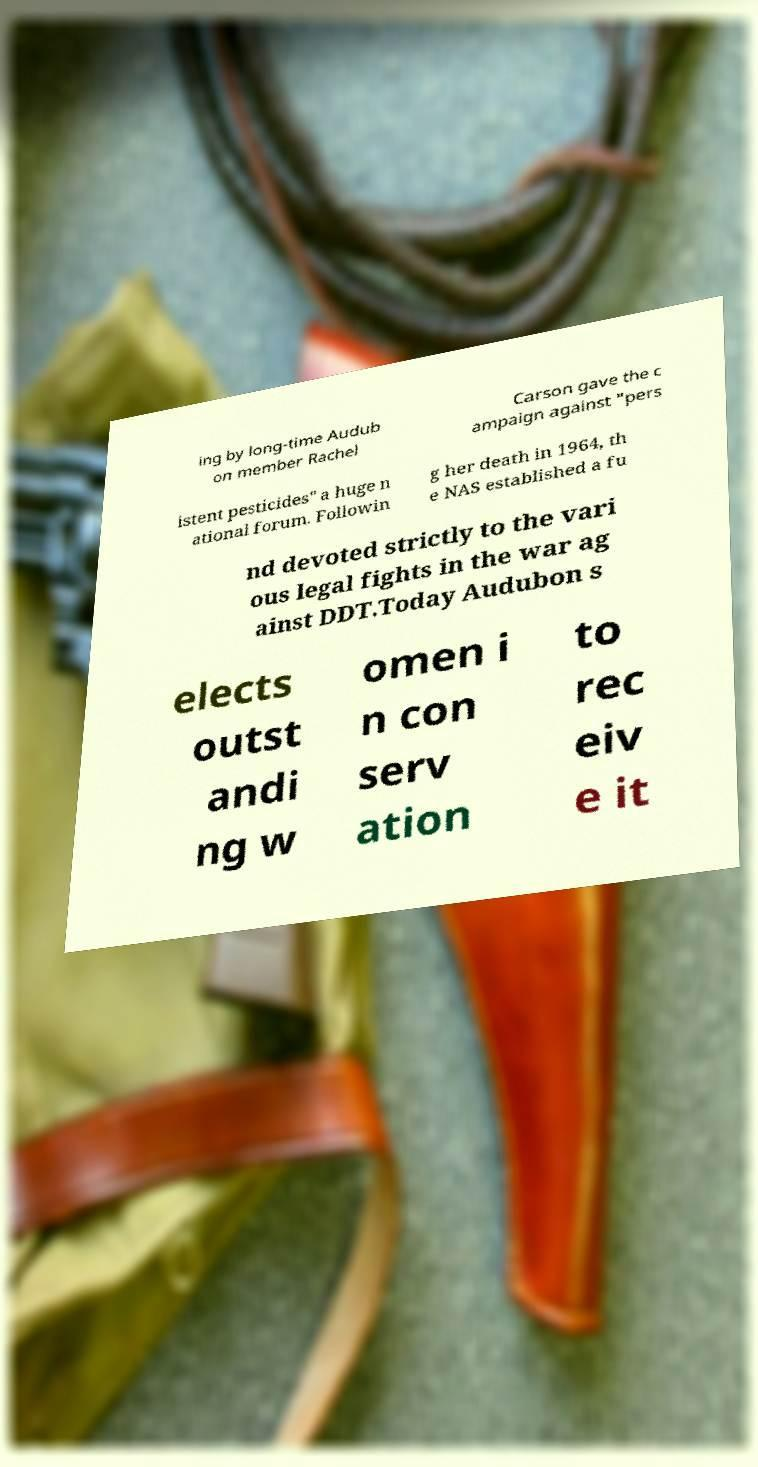Can you read and provide the text displayed in the image?This photo seems to have some interesting text. Can you extract and type it out for me? ing by long-time Audub on member Rachel Carson gave the c ampaign against "pers istent pesticides" a huge n ational forum. Followin g her death in 1964, th e NAS established a fu nd devoted strictly to the vari ous legal fights in the war ag ainst DDT.Today Audubon s elects outst andi ng w omen i n con serv ation to rec eiv e it 